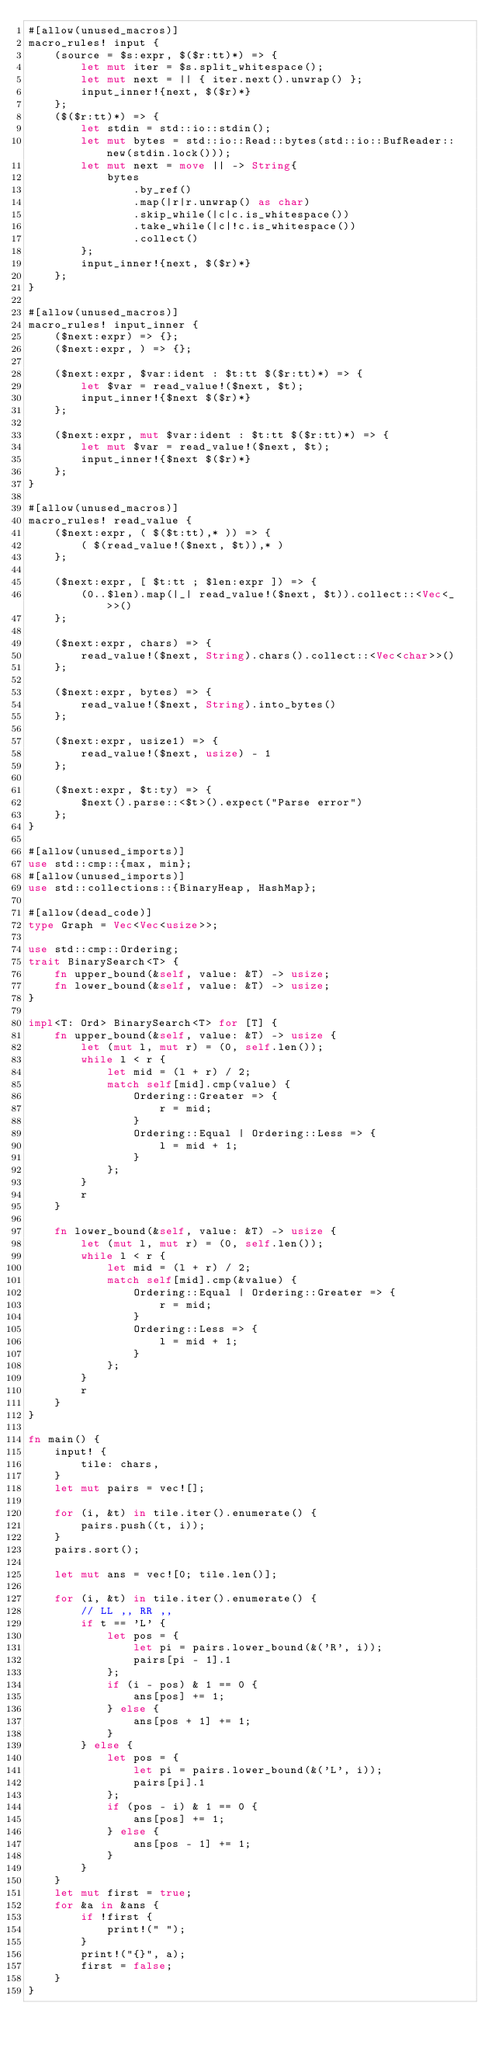<code> <loc_0><loc_0><loc_500><loc_500><_Rust_>#[allow(unused_macros)]
macro_rules! input {
    (source = $s:expr, $($r:tt)*) => {
        let mut iter = $s.split_whitespace();
        let mut next = || { iter.next().unwrap() };
        input_inner!{next, $($r)*}
    };
    ($($r:tt)*) => {
        let stdin = std::io::stdin();
        let mut bytes = std::io::Read::bytes(std::io::BufReader::new(stdin.lock()));
        let mut next = move || -> String{
            bytes
                .by_ref()
                .map(|r|r.unwrap() as char)
                .skip_while(|c|c.is_whitespace())
                .take_while(|c|!c.is_whitespace())
                .collect()
        };
        input_inner!{next, $($r)*}
    };
}

#[allow(unused_macros)]
macro_rules! input_inner {
    ($next:expr) => {};
    ($next:expr, ) => {};

    ($next:expr, $var:ident : $t:tt $($r:tt)*) => {
        let $var = read_value!($next, $t);
        input_inner!{$next $($r)*}
    };

    ($next:expr, mut $var:ident : $t:tt $($r:tt)*) => {
        let mut $var = read_value!($next, $t);
        input_inner!{$next $($r)*}
    };
}

#[allow(unused_macros)]
macro_rules! read_value {
    ($next:expr, ( $($t:tt),* )) => {
        ( $(read_value!($next, $t)),* )
    };

    ($next:expr, [ $t:tt ; $len:expr ]) => {
        (0..$len).map(|_| read_value!($next, $t)).collect::<Vec<_>>()
    };

    ($next:expr, chars) => {
        read_value!($next, String).chars().collect::<Vec<char>>()
    };

    ($next:expr, bytes) => {
        read_value!($next, String).into_bytes()
    };

    ($next:expr, usize1) => {
        read_value!($next, usize) - 1
    };

    ($next:expr, $t:ty) => {
        $next().parse::<$t>().expect("Parse error")
    };
}

#[allow(unused_imports)]
use std::cmp::{max, min};
#[allow(unused_imports)]
use std::collections::{BinaryHeap, HashMap};

#[allow(dead_code)]
type Graph = Vec<Vec<usize>>;

use std::cmp::Ordering;
trait BinarySearch<T> {
    fn upper_bound(&self, value: &T) -> usize;
    fn lower_bound(&self, value: &T) -> usize;
}

impl<T: Ord> BinarySearch<T> for [T] {
    fn upper_bound(&self, value: &T) -> usize {
        let (mut l, mut r) = (0, self.len());
        while l < r {
            let mid = (l + r) / 2;
            match self[mid].cmp(value) {
                Ordering::Greater => {
                    r = mid;
                }
                Ordering::Equal | Ordering::Less => {
                    l = mid + 1;
                }
            };
        }
        r
    }

    fn lower_bound(&self, value: &T) -> usize {
        let (mut l, mut r) = (0, self.len());
        while l < r {
            let mid = (l + r) / 2;
            match self[mid].cmp(&value) {
                Ordering::Equal | Ordering::Greater => {
                    r = mid;
                }
                Ordering::Less => {
                    l = mid + 1;
                }
            };
        }
        r
    }
}

fn main() {
    input! {
        tile: chars,
    }
    let mut pairs = vec![];

    for (i, &t) in tile.iter().enumerate() {
        pairs.push((t, i));
    }
    pairs.sort();

    let mut ans = vec![0; tile.len()];

    for (i, &t) in tile.iter().enumerate() {
        // LL ,, RR ,,
        if t == 'L' {
            let pos = {
                let pi = pairs.lower_bound(&('R', i));
                pairs[pi - 1].1
            };
            if (i - pos) & 1 == 0 {
                ans[pos] += 1;
            } else {
                ans[pos + 1] += 1;
            }
        } else {
            let pos = {
                let pi = pairs.lower_bound(&('L', i));
                pairs[pi].1
            };
            if (pos - i) & 1 == 0 {
                ans[pos] += 1;
            } else {
                ans[pos - 1] += 1;
            }
        }
    }
    let mut first = true;
    for &a in &ans {
        if !first {
            print!(" ");
        }
        print!("{}", a);
        first = false;
    }
}
</code> 